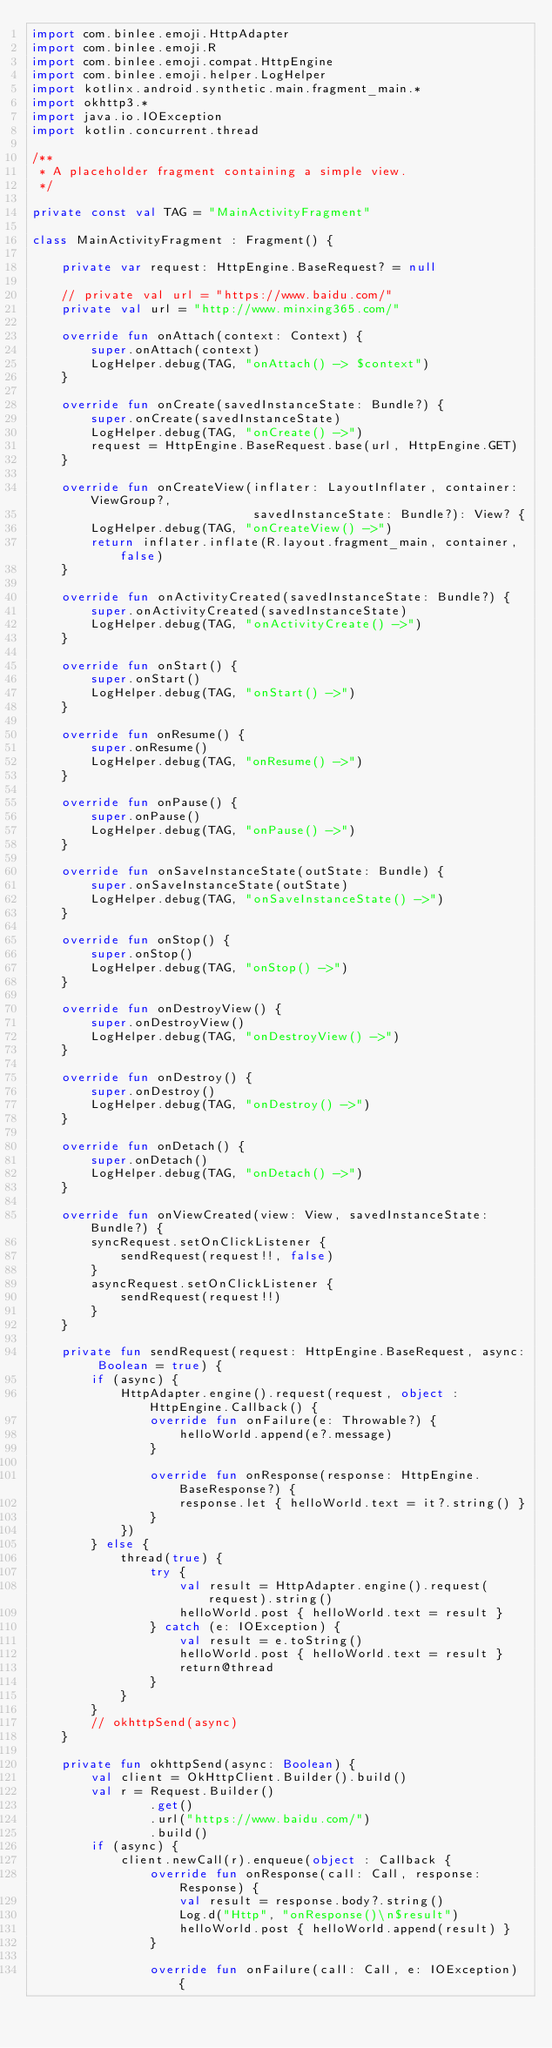<code> <loc_0><loc_0><loc_500><loc_500><_Kotlin_>import com.binlee.emoji.HttpAdapter
import com.binlee.emoji.R
import com.binlee.emoji.compat.HttpEngine
import com.binlee.emoji.helper.LogHelper
import kotlinx.android.synthetic.main.fragment_main.*
import okhttp3.*
import java.io.IOException
import kotlin.concurrent.thread

/**
 * A placeholder fragment containing a simple view.
 */

private const val TAG = "MainActivityFragment"

class MainActivityFragment : Fragment() {

    private var request: HttpEngine.BaseRequest? = null

    // private val url = "https://www.baidu.com/"
    private val url = "http://www.minxing365.com/"

    override fun onAttach(context: Context) {
        super.onAttach(context)
        LogHelper.debug(TAG, "onAttach() -> $context")
    }

    override fun onCreate(savedInstanceState: Bundle?) {
        super.onCreate(savedInstanceState)
        LogHelper.debug(TAG, "onCreate() ->")
        request = HttpEngine.BaseRequest.base(url, HttpEngine.GET)
    }

    override fun onCreateView(inflater: LayoutInflater, container: ViewGroup?,
                              savedInstanceState: Bundle?): View? {
        LogHelper.debug(TAG, "onCreateView() ->")
        return inflater.inflate(R.layout.fragment_main, container, false)
    }

    override fun onActivityCreated(savedInstanceState: Bundle?) {
        super.onActivityCreated(savedInstanceState)
        LogHelper.debug(TAG, "onActivityCreate() ->")
    }

    override fun onStart() {
        super.onStart()
        LogHelper.debug(TAG, "onStart() ->")
    }

    override fun onResume() {
        super.onResume()
        LogHelper.debug(TAG, "onResume() ->")
    }

    override fun onPause() {
        super.onPause()
        LogHelper.debug(TAG, "onPause() ->")
    }

    override fun onSaveInstanceState(outState: Bundle) {
        super.onSaveInstanceState(outState)
        LogHelper.debug(TAG, "onSaveInstanceState() ->")
    }

    override fun onStop() {
        super.onStop()
        LogHelper.debug(TAG, "onStop() ->")
    }

    override fun onDestroyView() {
        super.onDestroyView()
        LogHelper.debug(TAG, "onDestroyView() ->")
    }

    override fun onDestroy() {
        super.onDestroy()
        LogHelper.debug(TAG, "onDestroy() ->")
    }

    override fun onDetach() {
        super.onDetach()
        LogHelper.debug(TAG, "onDetach() ->")
    }

    override fun onViewCreated(view: View, savedInstanceState: Bundle?) {
        syncRequest.setOnClickListener {
            sendRequest(request!!, false)
        }
        asyncRequest.setOnClickListener {
            sendRequest(request!!)
        }
    }

    private fun sendRequest(request: HttpEngine.BaseRequest, async: Boolean = true) {
        if (async) {
            HttpAdapter.engine().request(request, object : HttpEngine.Callback() {
                override fun onFailure(e: Throwable?) {
                    helloWorld.append(e?.message)
                }

                override fun onResponse(response: HttpEngine.BaseResponse?) {
                    response.let { helloWorld.text = it?.string() }
                }
            })
        } else {
            thread(true) {
                try {
                    val result = HttpAdapter.engine().request(request).string()
                    helloWorld.post { helloWorld.text = result }
                } catch (e: IOException) {
                    val result = e.toString()
                    helloWorld.post { helloWorld.text = result }
                    return@thread
                }
            }
        }
        // okhttpSend(async)
    }

    private fun okhttpSend(async: Boolean) {
        val client = OkHttpClient.Builder().build()
        val r = Request.Builder()
                .get()
                .url("https://www.baidu.com/")
                .build()
        if (async) {
            client.newCall(r).enqueue(object : Callback {
                override fun onResponse(call: Call, response: Response) {
                    val result = response.body?.string()
                    Log.d("Http", "onResponse()\n$result")
                    helloWorld.post { helloWorld.append(result) }
                }

                override fun onFailure(call: Call, e: IOException) {</code> 